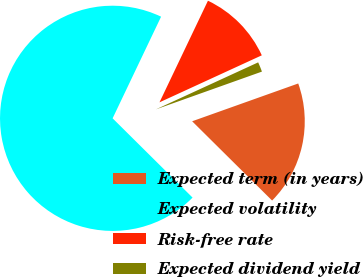Convert chart. <chart><loc_0><loc_0><loc_500><loc_500><pie_chart><fcel>Expected term (in years)<fcel>Expected volatility<fcel>Risk-free rate<fcel>Expected dividend yield<nl><fcel>17.88%<fcel>69.65%<fcel>11.06%<fcel>1.41%<nl></chart> 